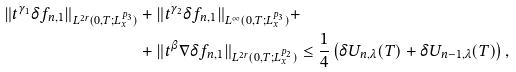<formula> <loc_0><loc_0><loc_500><loc_500>\| t ^ { \gamma _ { 1 } } \delta f _ { n , 1 } \| _ { L ^ { 2 r } ( 0 , T ; L ^ { p _ { 3 } } _ { x } ) } & + \| t ^ { \gamma _ { 2 } } \delta f _ { n , 1 } \| _ { L ^ { \infty } ( 0 , T ; L ^ { p _ { 3 } } _ { x } ) } + \\ & + \| t ^ { \beta } \nabla \delta f _ { n , 1 } \| _ { L ^ { 2 r } ( 0 , T ; L ^ { p _ { 2 } } _ { x } ) } \leq \frac { 1 } { 4 } \left ( \delta U _ { n , \lambda } ( T ) + \delta U _ { n - 1 , \lambda } ( T ) \right ) ,</formula> 